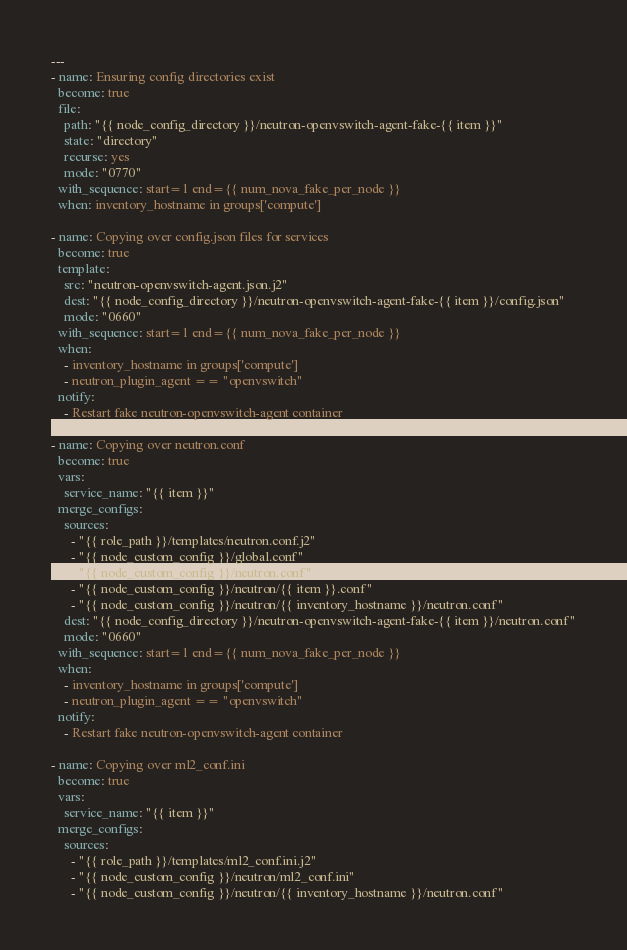<code> <loc_0><loc_0><loc_500><loc_500><_YAML_>---
- name: Ensuring config directories exist
  become: true
  file:
    path: "{{ node_config_directory }}/neutron-openvswitch-agent-fake-{{ item }}"
    state: "directory"
    recurse: yes
    mode: "0770"
  with_sequence: start=1 end={{ num_nova_fake_per_node }}
  when: inventory_hostname in groups['compute']

- name: Copying over config.json files for services
  become: true
  template:
    src: "neutron-openvswitch-agent.json.j2"
    dest: "{{ node_config_directory }}/neutron-openvswitch-agent-fake-{{ item }}/config.json"
    mode: "0660"
  with_sequence: start=1 end={{ num_nova_fake_per_node }}
  when:
    - inventory_hostname in groups['compute']
    - neutron_plugin_agent == "openvswitch"
  notify:
    - Restart fake neutron-openvswitch-agent container

- name: Copying over neutron.conf
  become: true
  vars:
    service_name: "{{ item }}"
  merge_configs:
    sources:
      - "{{ role_path }}/templates/neutron.conf.j2"
      - "{{ node_custom_config }}/global.conf"
      - "{{ node_custom_config }}/neutron.conf"
      - "{{ node_custom_config }}/neutron/{{ item }}.conf"
      - "{{ node_custom_config }}/neutron/{{ inventory_hostname }}/neutron.conf"
    dest: "{{ node_config_directory }}/neutron-openvswitch-agent-fake-{{ item }}/neutron.conf"
    mode: "0660"
  with_sequence: start=1 end={{ num_nova_fake_per_node }}
  when:
    - inventory_hostname in groups['compute']
    - neutron_plugin_agent == "openvswitch"
  notify:
    - Restart fake neutron-openvswitch-agent container

- name: Copying over ml2_conf.ini
  become: true
  vars:
    service_name: "{{ item }}"
  merge_configs:
    sources:
      - "{{ role_path }}/templates/ml2_conf.ini.j2"
      - "{{ node_custom_config }}/neutron/ml2_conf.ini"
      - "{{ node_custom_config }}/neutron/{{ inventory_hostname }}/neutron.conf"</code> 